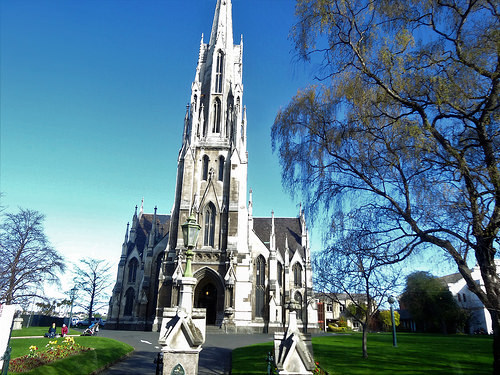<image>
Can you confirm if the church is next to the tree? Yes. The church is positioned adjacent to the tree, located nearby in the same general area. 